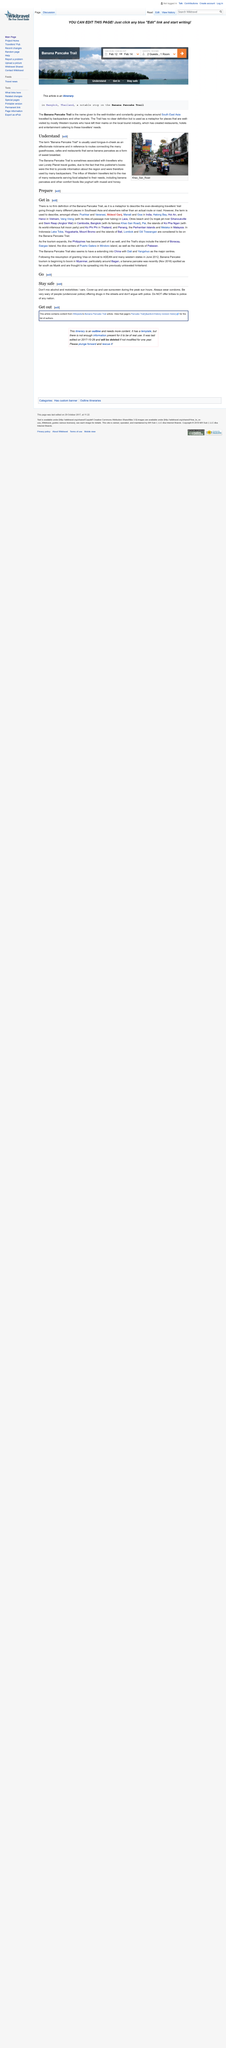Highlight a few significant elements in this photo. In addition to banana pancakes, other foods are served to Western travelers. Yoghurt with muesli and honey is another example of a dish offered to visitors. Khao San Road is a well-known and famous road in the city of Bangkok. The locations that served banana pancakes to backpackers and Western travelers were guesthouses, cafes, and restaurants. The countries that are often visited by travelers following the popular tourist route known as the "Banana Pancake Trail" are Vietnam, Laos, Cambodia, Bangkok, Thailand, Malaysia, Indonesia, and Bali. The Banana Pancake Trail is a metaphor that refers to the ever-developing trail of travelers who journey through various places in Southeast Asia and beyond, rather than a specific route or road. 